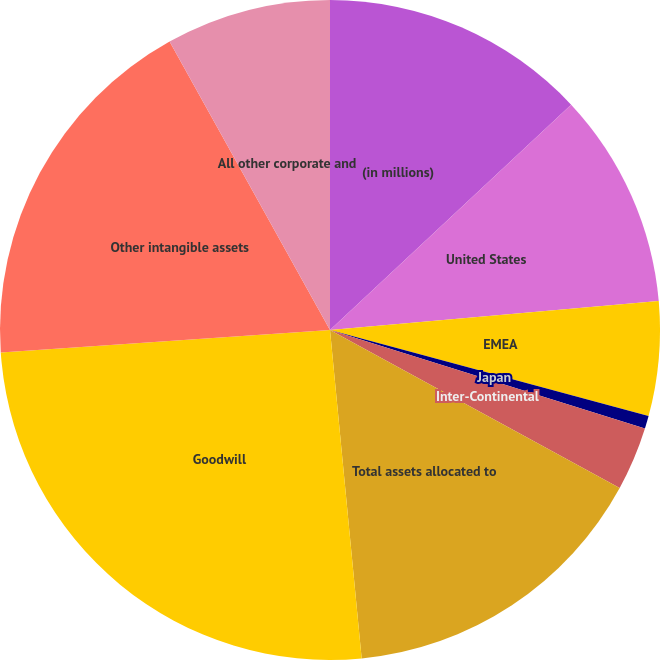<chart> <loc_0><loc_0><loc_500><loc_500><pie_chart><fcel>(in millions)<fcel>United States<fcel>EMEA<fcel>Japan<fcel>Inter-Continental<fcel>Total assets allocated to<fcel>Goodwill<fcel>Other intangible assets<fcel>All other corporate and<nl><fcel>13.04%<fcel>10.56%<fcel>5.6%<fcel>0.63%<fcel>3.12%<fcel>15.52%<fcel>25.45%<fcel>18.0%<fcel>8.08%<nl></chart> 